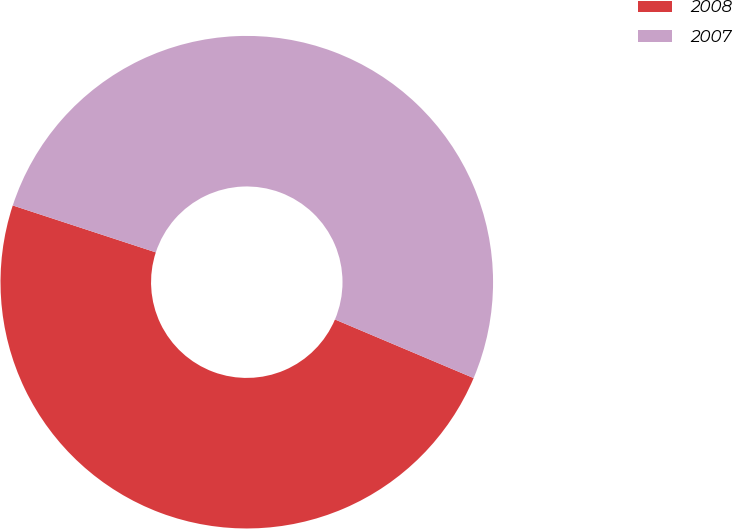<chart> <loc_0><loc_0><loc_500><loc_500><pie_chart><fcel>2008<fcel>2007<nl><fcel>48.68%<fcel>51.32%<nl></chart> 